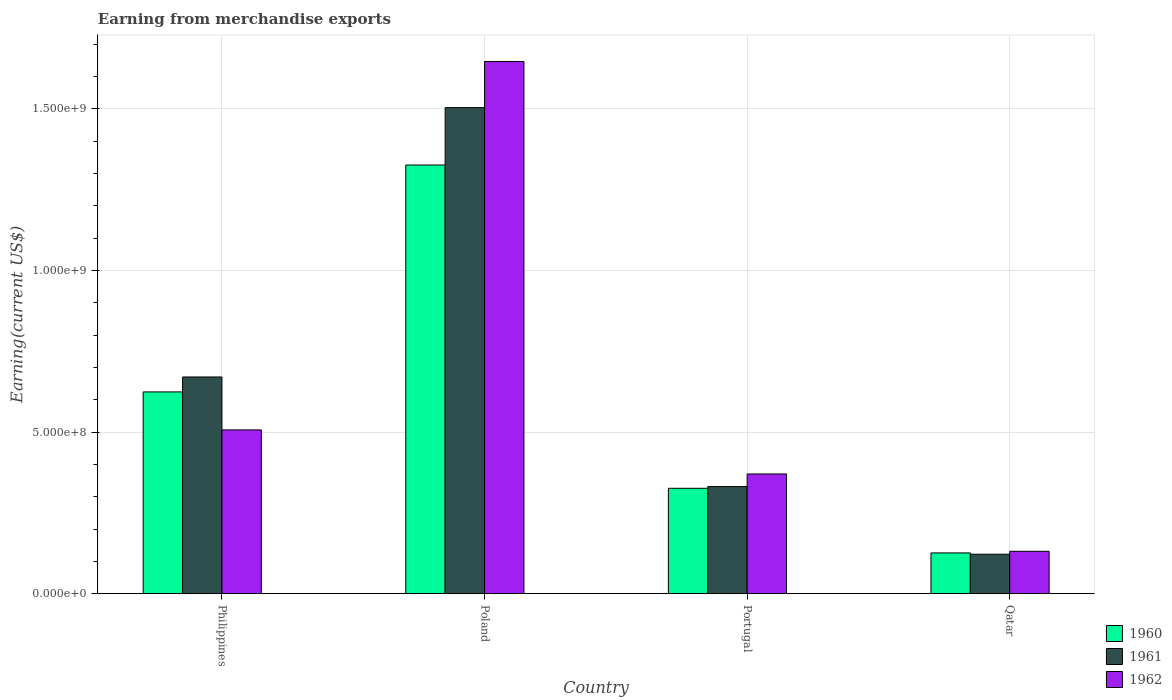How many groups of bars are there?
Give a very brief answer. 4. How many bars are there on the 3rd tick from the left?
Your answer should be very brief. 3. What is the label of the 2nd group of bars from the left?
Ensure brevity in your answer.  Poland. What is the amount earned from merchandise exports in 1961 in Portugal?
Offer a very short reply. 3.31e+08. Across all countries, what is the maximum amount earned from merchandise exports in 1960?
Offer a terse response. 1.33e+09. Across all countries, what is the minimum amount earned from merchandise exports in 1962?
Provide a succinct answer. 1.31e+08. In which country was the amount earned from merchandise exports in 1961 maximum?
Make the answer very short. Poland. In which country was the amount earned from merchandise exports in 1961 minimum?
Offer a terse response. Qatar. What is the total amount earned from merchandise exports in 1960 in the graph?
Keep it short and to the point. 2.40e+09. What is the difference between the amount earned from merchandise exports in 1960 in Philippines and that in Poland?
Offer a terse response. -7.02e+08. What is the difference between the amount earned from merchandise exports in 1962 in Qatar and the amount earned from merchandise exports in 1960 in Philippines?
Your answer should be compact. -4.93e+08. What is the average amount earned from merchandise exports in 1961 per country?
Provide a succinct answer. 6.57e+08. What is the difference between the amount earned from merchandise exports of/in 1961 and amount earned from merchandise exports of/in 1960 in Poland?
Your response must be concise. 1.78e+08. In how many countries, is the amount earned from merchandise exports in 1962 greater than 800000000 US$?
Provide a short and direct response. 1. What is the ratio of the amount earned from merchandise exports in 1962 in Portugal to that in Qatar?
Give a very brief answer. 2.83. What is the difference between the highest and the second highest amount earned from merchandise exports in 1962?
Your answer should be compact. 1.28e+09. What is the difference between the highest and the lowest amount earned from merchandise exports in 1962?
Your answer should be very brief. 1.52e+09. Is the sum of the amount earned from merchandise exports in 1960 in Portugal and Qatar greater than the maximum amount earned from merchandise exports in 1961 across all countries?
Ensure brevity in your answer.  No. How many bars are there?
Your response must be concise. 12. Are all the bars in the graph horizontal?
Make the answer very short. No. How many countries are there in the graph?
Provide a succinct answer. 4. Does the graph contain any zero values?
Offer a terse response. No. Does the graph contain grids?
Your response must be concise. Yes. Where does the legend appear in the graph?
Make the answer very short. Bottom right. How are the legend labels stacked?
Make the answer very short. Vertical. What is the title of the graph?
Provide a succinct answer. Earning from merchandise exports. Does "1982" appear as one of the legend labels in the graph?
Ensure brevity in your answer.  No. What is the label or title of the Y-axis?
Offer a very short reply. Earning(current US$). What is the Earning(current US$) of 1960 in Philippines?
Your response must be concise. 6.24e+08. What is the Earning(current US$) in 1961 in Philippines?
Offer a terse response. 6.70e+08. What is the Earning(current US$) in 1962 in Philippines?
Offer a very short reply. 5.07e+08. What is the Earning(current US$) in 1960 in Poland?
Your answer should be very brief. 1.33e+09. What is the Earning(current US$) in 1961 in Poland?
Your response must be concise. 1.50e+09. What is the Earning(current US$) of 1962 in Poland?
Offer a very short reply. 1.65e+09. What is the Earning(current US$) of 1960 in Portugal?
Your answer should be compact. 3.26e+08. What is the Earning(current US$) of 1961 in Portugal?
Your answer should be very brief. 3.31e+08. What is the Earning(current US$) of 1962 in Portugal?
Your answer should be very brief. 3.70e+08. What is the Earning(current US$) of 1960 in Qatar?
Your answer should be compact. 1.26e+08. What is the Earning(current US$) of 1961 in Qatar?
Keep it short and to the point. 1.22e+08. What is the Earning(current US$) in 1962 in Qatar?
Provide a short and direct response. 1.31e+08. Across all countries, what is the maximum Earning(current US$) in 1960?
Offer a very short reply. 1.33e+09. Across all countries, what is the maximum Earning(current US$) in 1961?
Make the answer very short. 1.50e+09. Across all countries, what is the maximum Earning(current US$) of 1962?
Give a very brief answer. 1.65e+09. Across all countries, what is the minimum Earning(current US$) in 1960?
Your response must be concise. 1.26e+08. Across all countries, what is the minimum Earning(current US$) in 1961?
Ensure brevity in your answer.  1.22e+08. Across all countries, what is the minimum Earning(current US$) of 1962?
Offer a very short reply. 1.31e+08. What is the total Earning(current US$) of 1960 in the graph?
Your answer should be very brief. 2.40e+09. What is the total Earning(current US$) in 1961 in the graph?
Ensure brevity in your answer.  2.63e+09. What is the total Earning(current US$) in 1962 in the graph?
Provide a short and direct response. 2.65e+09. What is the difference between the Earning(current US$) of 1960 in Philippines and that in Poland?
Offer a very short reply. -7.02e+08. What is the difference between the Earning(current US$) of 1961 in Philippines and that in Poland?
Your response must be concise. -8.33e+08. What is the difference between the Earning(current US$) of 1962 in Philippines and that in Poland?
Your response must be concise. -1.14e+09. What is the difference between the Earning(current US$) in 1960 in Philippines and that in Portugal?
Your answer should be very brief. 2.98e+08. What is the difference between the Earning(current US$) of 1961 in Philippines and that in Portugal?
Make the answer very short. 3.39e+08. What is the difference between the Earning(current US$) of 1962 in Philippines and that in Portugal?
Your answer should be compact. 1.36e+08. What is the difference between the Earning(current US$) in 1960 in Philippines and that in Qatar?
Ensure brevity in your answer.  4.98e+08. What is the difference between the Earning(current US$) of 1961 in Philippines and that in Qatar?
Keep it short and to the point. 5.48e+08. What is the difference between the Earning(current US$) of 1962 in Philippines and that in Qatar?
Your response must be concise. 3.76e+08. What is the difference between the Earning(current US$) in 1960 in Poland and that in Portugal?
Provide a short and direct response. 1.00e+09. What is the difference between the Earning(current US$) of 1961 in Poland and that in Portugal?
Offer a very short reply. 1.17e+09. What is the difference between the Earning(current US$) of 1962 in Poland and that in Portugal?
Keep it short and to the point. 1.28e+09. What is the difference between the Earning(current US$) of 1960 in Poland and that in Qatar?
Keep it short and to the point. 1.20e+09. What is the difference between the Earning(current US$) of 1961 in Poland and that in Qatar?
Your answer should be very brief. 1.38e+09. What is the difference between the Earning(current US$) of 1962 in Poland and that in Qatar?
Keep it short and to the point. 1.52e+09. What is the difference between the Earning(current US$) of 1960 in Portugal and that in Qatar?
Offer a terse response. 2.00e+08. What is the difference between the Earning(current US$) of 1961 in Portugal and that in Qatar?
Give a very brief answer. 2.09e+08. What is the difference between the Earning(current US$) of 1962 in Portugal and that in Qatar?
Give a very brief answer. 2.39e+08. What is the difference between the Earning(current US$) in 1960 in Philippines and the Earning(current US$) in 1961 in Poland?
Your answer should be very brief. -8.79e+08. What is the difference between the Earning(current US$) in 1960 in Philippines and the Earning(current US$) in 1962 in Poland?
Your answer should be very brief. -1.02e+09. What is the difference between the Earning(current US$) in 1961 in Philippines and the Earning(current US$) in 1962 in Poland?
Make the answer very short. -9.76e+08. What is the difference between the Earning(current US$) of 1960 in Philippines and the Earning(current US$) of 1961 in Portugal?
Your answer should be very brief. 2.93e+08. What is the difference between the Earning(current US$) in 1960 in Philippines and the Earning(current US$) in 1962 in Portugal?
Your answer should be very brief. 2.54e+08. What is the difference between the Earning(current US$) in 1961 in Philippines and the Earning(current US$) in 1962 in Portugal?
Provide a succinct answer. 3.00e+08. What is the difference between the Earning(current US$) of 1960 in Philippines and the Earning(current US$) of 1961 in Qatar?
Provide a succinct answer. 5.02e+08. What is the difference between the Earning(current US$) in 1960 in Philippines and the Earning(current US$) in 1962 in Qatar?
Make the answer very short. 4.93e+08. What is the difference between the Earning(current US$) in 1961 in Philippines and the Earning(current US$) in 1962 in Qatar?
Your answer should be compact. 5.39e+08. What is the difference between the Earning(current US$) in 1960 in Poland and the Earning(current US$) in 1961 in Portugal?
Give a very brief answer. 9.95e+08. What is the difference between the Earning(current US$) of 1960 in Poland and the Earning(current US$) of 1962 in Portugal?
Provide a short and direct response. 9.56e+08. What is the difference between the Earning(current US$) of 1961 in Poland and the Earning(current US$) of 1962 in Portugal?
Your response must be concise. 1.13e+09. What is the difference between the Earning(current US$) in 1960 in Poland and the Earning(current US$) in 1961 in Qatar?
Provide a succinct answer. 1.20e+09. What is the difference between the Earning(current US$) of 1960 in Poland and the Earning(current US$) of 1962 in Qatar?
Give a very brief answer. 1.20e+09. What is the difference between the Earning(current US$) of 1961 in Poland and the Earning(current US$) of 1962 in Qatar?
Provide a short and direct response. 1.37e+09. What is the difference between the Earning(current US$) of 1960 in Portugal and the Earning(current US$) of 1961 in Qatar?
Your response must be concise. 2.04e+08. What is the difference between the Earning(current US$) in 1960 in Portugal and the Earning(current US$) in 1962 in Qatar?
Offer a very short reply. 1.95e+08. What is the difference between the Earning(current US$) in 1961 in Portugal and the Earning(current US$) in 1962 in Qatar?
Offer a terse response. 2.00e+08. What is the average Earning(current US$) in 1960 per country?
Provide a succinct answer. 6.01e+08. What is the average Earning(current US$) in 1961 per country?
Give a very brief answer. 6.57e+08. What is the average Earning(current US$) of 1962 per country?
Provide a short and direct response. 6.64e+08. What is the difference between the Earning(current US$) of 1960 and Earning(current US$) of 1961 in Philippines?
Make the answer very short. -4.62e+07. What is the difference between the Earning(current US$) of 1960 and Earning(current US$) of 1962 in Philippines?
Provide a succinct answer. 1.18e+08. What is the difference between the Earning(current US$) in 1961 and Earning(current US$) in 1962 in Philippines?
Make the answer very short. 1.64e+08. What is the difference between the Earning(current US$) of 1960 and Earning(current US$) of 1961 in Poland?
Your answer should be compact. -1.78e+08. What is the difference between the Earning(current US$) of 1960 and Earning(current US$) of 1962 in Poland?
Your answer should be very brief. -3.20e+08. What is the difference between the Earning(current US$) of 1961 and Earning(current US$) of 1962 in Poland?
Your answer should be very brief. -1.43e+08. What is the difference between the Earning(current US$) in 1960 and Earning(current US$) in 1961 in Portugal?
Offer a very short reply. -5.25e+06. What is the difference between the Earning(current US$) in 1960 and Earning(current US$) in 1962 in Portugal?
Offer a very short reply. -4.43e+07. What is the difference between the Earning(current US$) of 1961 and Earning(current US$) of 1962 in Portugal?
Offer a terse response. -3.91e+07. What is the difference between the Earning(current US$) of 1960 and Earning(current US$) of 1961 in Qatar?
Your answer should be very brief. 4.00e+06. What is the difference between the Earning(current US$) of 1960 and Earning(current US$) of 1962 in Qatar?
Your response must be concise. -5.00e+06. What is the difference between the Earning(current US$) in 1961 and Earning(current US$) in 1962 in Qatar?
Offer a very short reply. -9.00e+06. What is the ratio of the Earning(current US$) of 1960 in Philippines to that in Poland?
Ensure brevity in your answer.  0.47. What is the ratio of the Earning(current US$) of 1961 in Philippines to that in Poland?
Your answer should be very brief. 0.45. What is the ratio of the Earning(current US$) of 1962 in Philippines to that in Poland?
Your answer should be very brief. 0.31. What is the ratio of the Earning(current US$) in 1960 in Philippines to that in Portugal?
Offer a very short reply. 1.91. What is the ratio of the Earning(current US$) of 1961 in Philippines to that in Portugal?
Provide a succinct answer. 2.02. What is the ratio of the Earning(current US$) of 1962 in Philippines to that in Portugal?
Keep it short and to the point. 1.37. What is the ratio of the Earning(current US$) of 1960 in Philippines to that in Qatar?
Provide a succinct answer. 4.95. What is the ratio of the Earning(current US$) in 1961 in Philippines to that in Qatar?
Your answer should be very brief. 5.49. What is the ratio of the Earning(current US$) of 1962 in Philippines to that in Qatar?
Keep it short and to the point. 3.87. What is the ratio of the Earning(current US$) in 1960 in Poland to that in Portugal?
Keep it short and to the point. 4.07. What is the ratio of the Earning(current US$) of 1961 in Poland to that in Portugal?
Provide a short and direct response. 4.54. What is the ratio of the Earning(current US$) in 1962 in Poland to that in Portugal?
Offer a very short reply. 4.45. What is the ratio of the Earning(current US$) of 1960 in Poland to that in Qatar?
Your response must be concise. 10.52. What is the ratio of the Earning(current US$) in 1961 in Poland to that in Qatar?
Ensure brevity in your answer.  12.32. What is the ratio of the Earning(current US$) of 1962 in Poland to that in Qatar?
Provide a succinct answer. 12.57. What is the ratio of the Earning(current US$) in 1960 in Portugal to that in Qatar?
Offer a very short reply. 2.59. What is the ratio of the Earning(current US$) of 1961 in Portugal to that in Qatar?
Offer a terse response. 2.71. What is the ratio of the Earning(current US$) of 1962 in Portugal to that in Qatar?
Offer a very short reply. 2.83. What is the difference between the highest and the second highest Earning(current US$) of 1960?
Your answer should be very brief. 7.02e+08. What is the difference between the highest and the second highest Earning(current US$) in 1961?
Keep it short and to the point. 8.33e+08. What is the difference between the highest and the second highest Earning(current US$) in 1962?
Offer a terse response. 1.14e+09. What is the difference between the highest and the lowest Earning(current US$) in 1960?
Ensure brevity in your answer.  1.20e+09. What is the difference between the highest and the lowest Earning(current US$) in 1961?
Your response must be concise. 1.38e+09. What is the difference between the highest and the lowest Earning(current US$) of 1962?
Your response must be concise. 1.52e+09. 